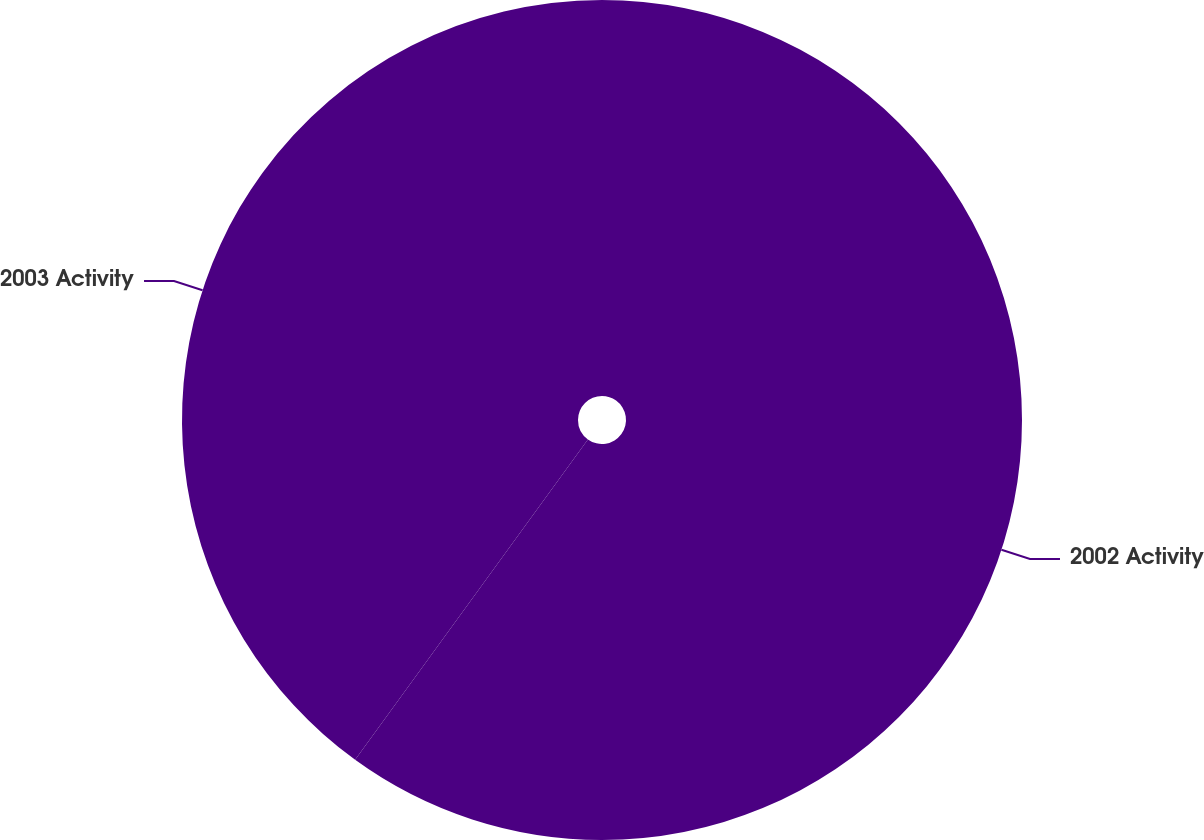Convert chart. <chart><loc_0><loc_0><loc_500><loc_500><pie_chart><fcel>2002 Activity<fcel>2003 Activity<nl><fcel>60.0%<fcel>40.0%<nl></chart> 